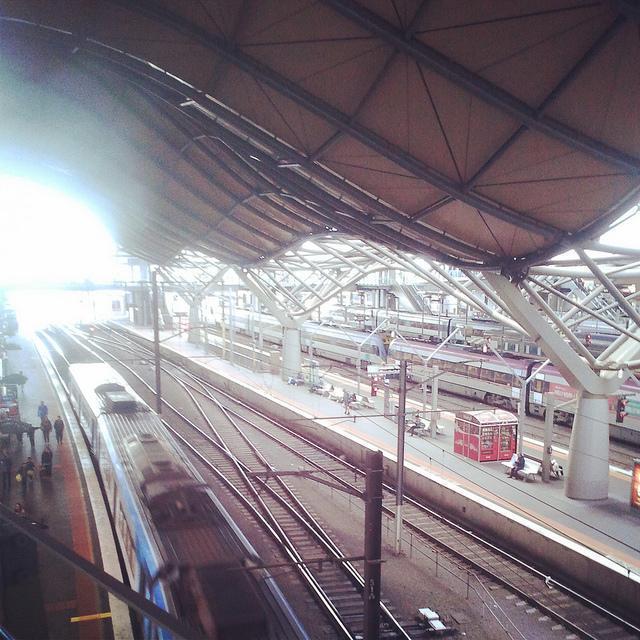How many trains are in the photo?
Give a very brief answer. 3. How many dogs are here?
Give a very brief answer. 0. 